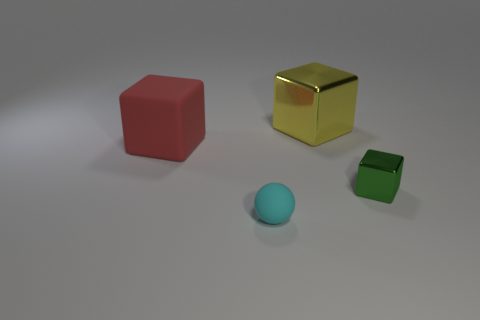Add 2 yellow metal things. How many objects exist? 6 Subtract all spheres. How many objects are left? 3 Subtract all small yellow matte cubes. Subtract all shiny cubes. How many objects are left? 2 Add 4 big yellow metallic objects. How many big yellow metallic objects are left? 5 Add 4 big rubber cubes. How many big rubber cubes exist? 5 Subtract 0 blue cylinders. How many objects are left? 4 